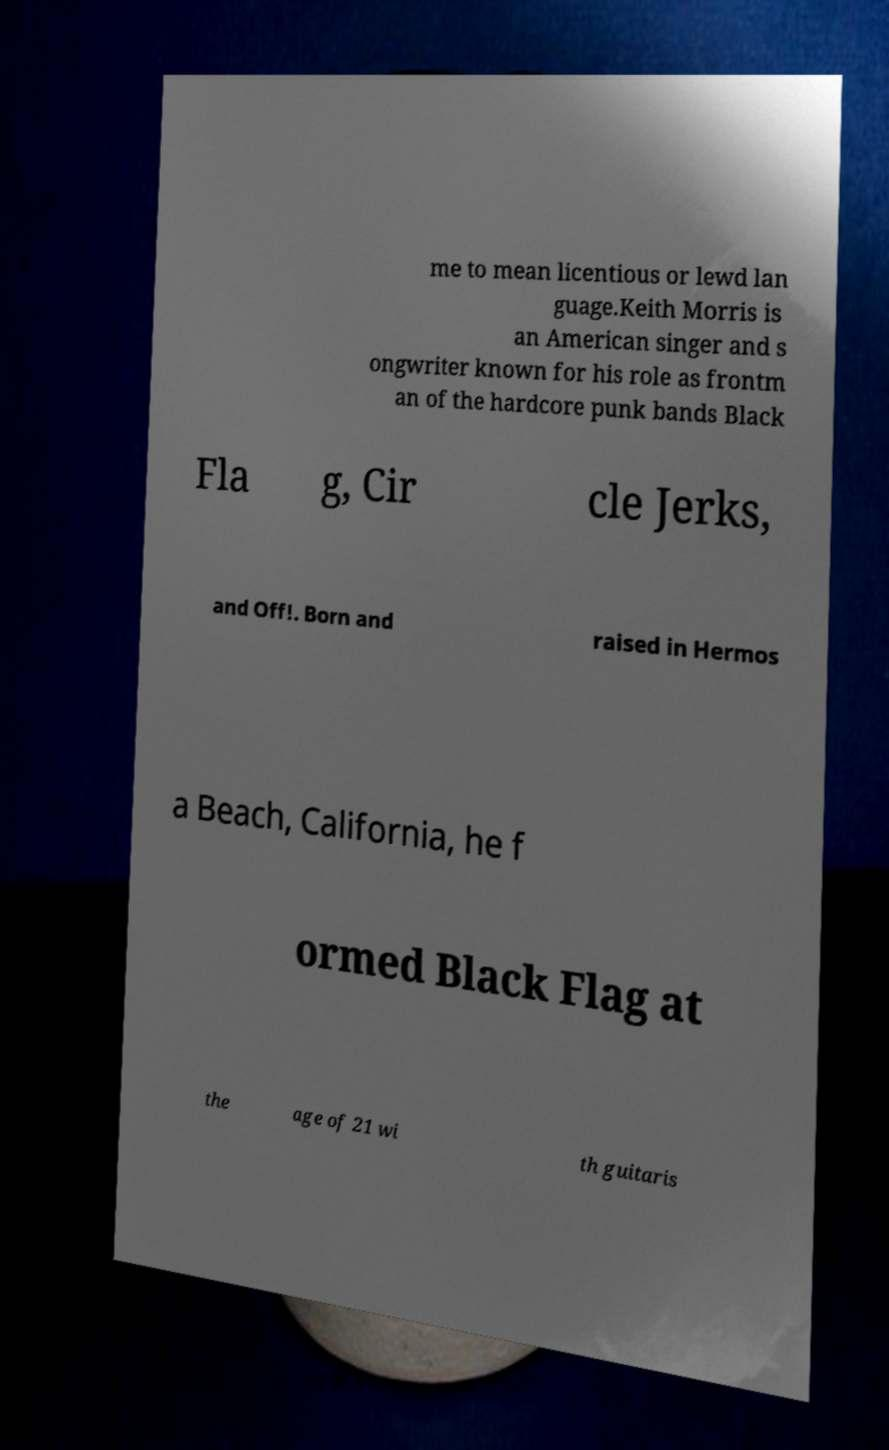There's text embedded in this image that I need extracted. Can you transcribe it verbatim? me to mean licentious or lewd lan guage.Keith Morris is an American singer and s ongwriter known for his role as frontm an of the hardcore punk bands Black Fla g, Cir cle Jerks, and Off!. Born and raised in Hermos a Beach, California, he f ormed Black Flag at the age of 21 wi th guitaris 